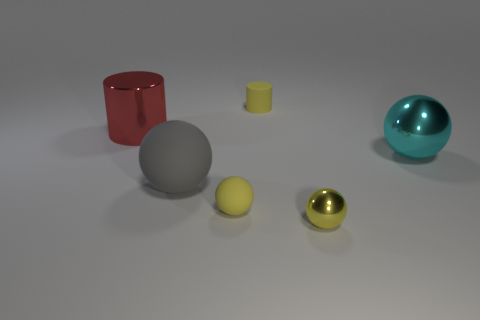Add 3 big matte spheres. How many objects exist? 9 Subtract all cylinders. How many objects are left? 4 Subtract all red cylinders. Subtract all cyan balls. How many objects are left? 4 Add 2 small matte cylinders. How many small matte cylinders are left? 3 Add 3 spheres. How many spheres exist? 7 Subtract 0 purple cylinders. How many objects are left? 6 